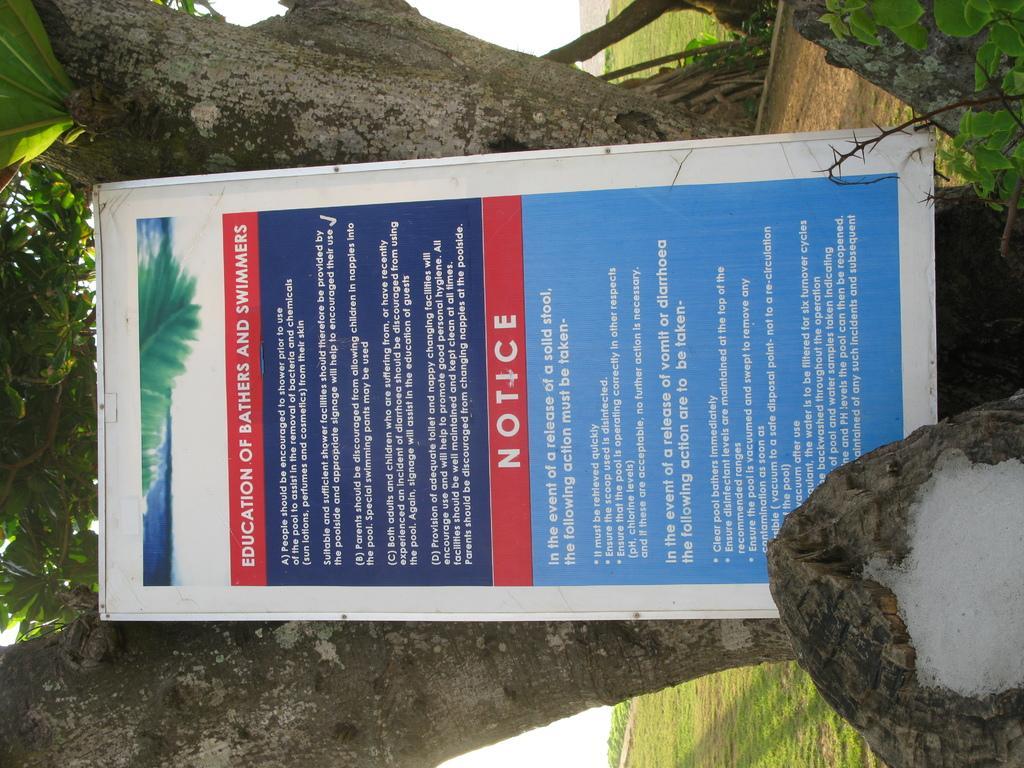Can you describe this image briefly? In this image, we can see a board in front of the tree. 